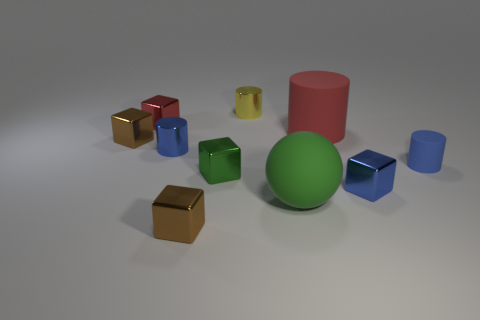What size is the other matte object that is the same shape as the big red matte object?
Provide a short and direct response. Small. There is a tiny blue object to the right of the small blue metal thing to the right of the red rubber cylinder; what is its material?
Your answer should be compact. Rubber. What number of matte objects are either tiny yellow cubes or blue cubes?
Give a very brief answer. 0. What is the color of the other small rubber object that is the same shape as the yellow object?
Offer a very short reply. Blue. What number of blocks have the same color as the rubber ball?
Keep it short and to the point. 1. Is there a small cylinder that is right of the brown object that is in front of the tiny matte cylinder?
Your answer should be compact. Yes. How many things are in front of the tiny red thing and to the right of the small green cube?
Your answer should be compact. 4. How many large things have the same material as the big red cylinder?
Make the answer very short. 1. There is a matte cylinder that is behind the cylinder that is right of the blue metal block; how big is it?
Provide a short and direct response. Large. Are there any blue objects of the same shape as the tiny yellow metallic object?
Make the answer very short. Yes. 